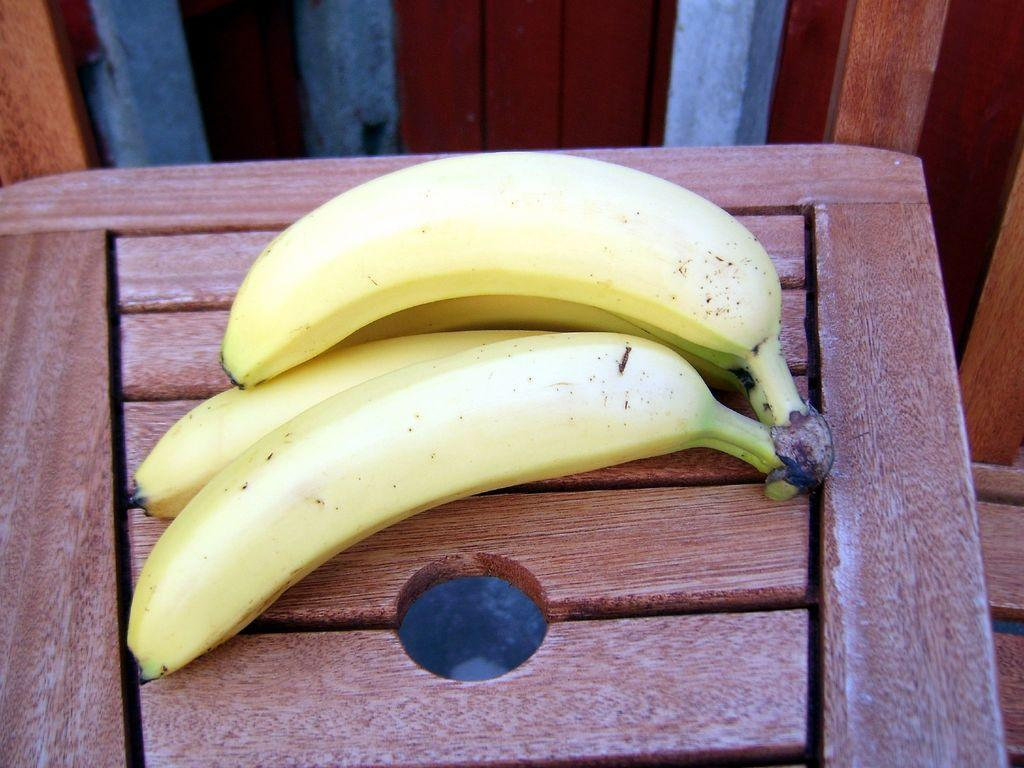What type of fruit is present in the image? There are bananas in the image. Where are the bananas located? The bananas are on a chair. What type of range can be seen in the image? There is no range present in the image; it only features bananas on a chair. What type of stitch is used to hold the bananas together in the image? There is no stitching involved in the image; the bananas are simply placed on the chair. 